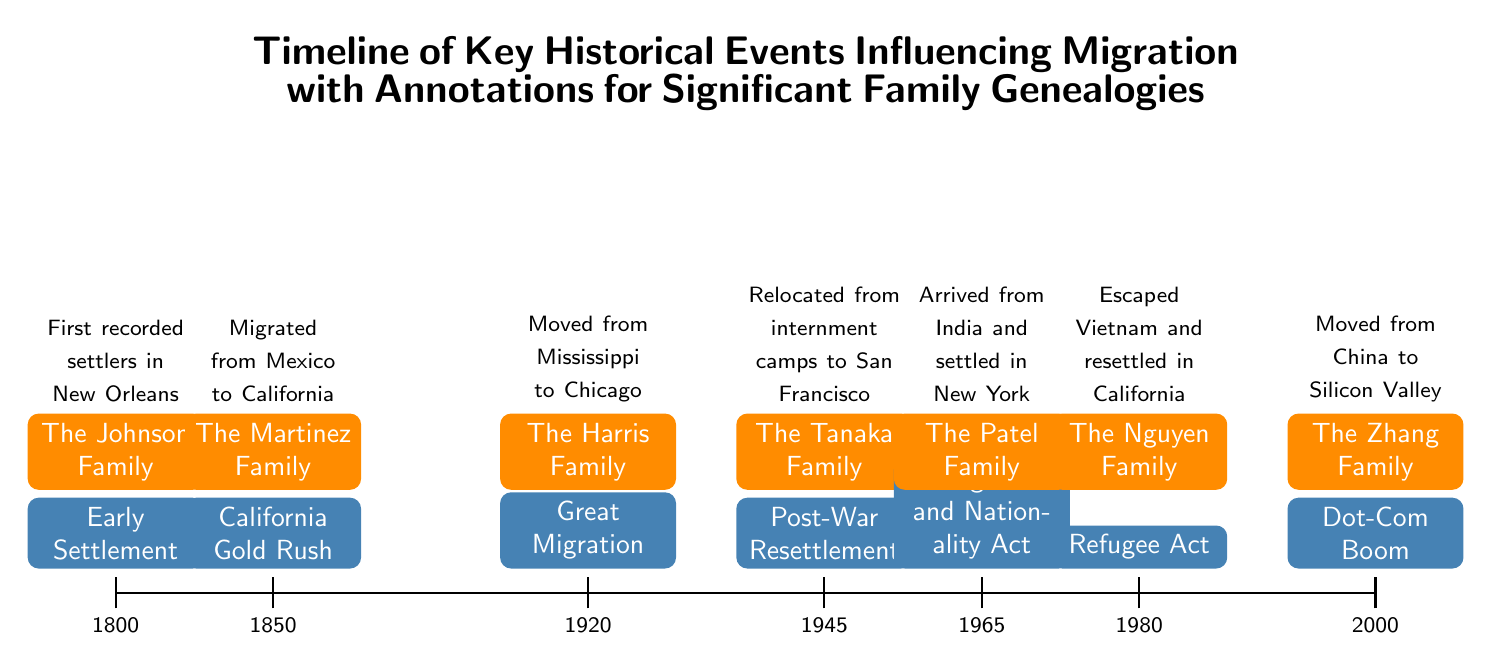What historical event is recorded at 1850? The diagram indicates the California Gold Rush occurring at the year 1850, highlighted in the timeline.
Answer: California Gold Rush Which family migrated to California during the California Gold Rush? The diagram specifies that the Martinez Family migrated from Mexico to California during the California Gold Rush event.
Answer: The Martinez Family How many significant family genealogies are annotated in the timeline? By examining the diagram, we find a total of six family genealogies annotated corresponding to key historical events on the timeline.
Answer: Six What is the earliest event listed in the timeline? The earliest event indicated on the timeline is Early Settlement, occurring in the year 1800, which is the first entry in the diagram.
Answer: Early Settlement Which family is associated with the Post-War Resettlement? The diagram shows that the Tanaka Family is connected with the Post-War Resettlement event, which took place in 1945.
Answer: The Tanaka Family What year did the Immigration and Nationality Act occur? The timeline marks the Immigration and Nationality Act occurring in the year 1965, which is the fifth entry on the timeline.
Answer: 1965 Which two families are from California in the timeline? By reviewing the diagram, it can be seen that both the Tanaka Family and the Nguyen Family relocated to California, as indicated by their respective events.
Answer: The Tanaka Family and The Nguyen Family What was the ethnic origin of the Zhang Family in the timeline? The diagram indicates that the Zhang Family moved from China, specifying their ethnic origin related to their migration in 2000.
Answer: China 